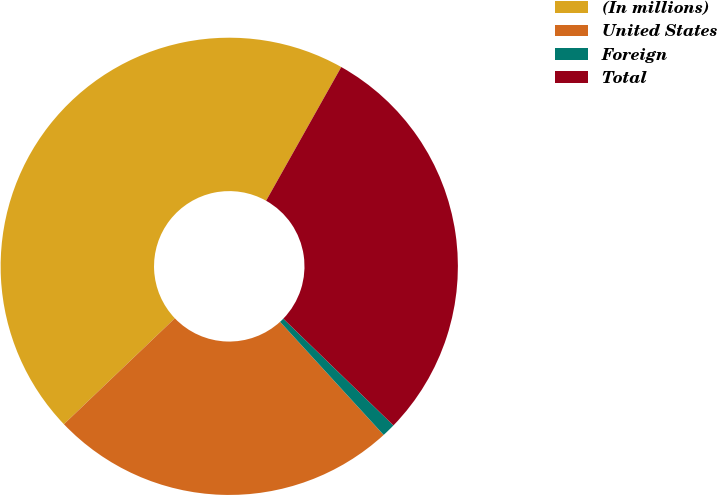<chart> <loc_0><loc_0><loc_500><loc_500><pie_chart><fcel>(In millions)<fcel>United States<fcel>Foreign<fcel>Total<nl><fcel>45.28%<fcel>24.67%<fcel>0.95%<fcel>29.1%<nl></chart> 